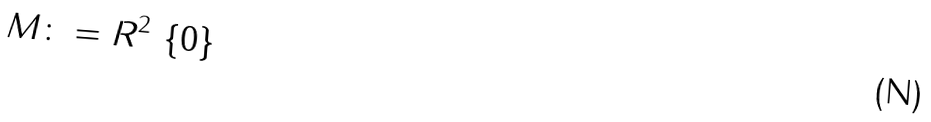Convert formula to latex. <formula><loc_0><loc_0><loc_500><loc_500>M \colon = R ^ { 2 } \ \{ 0 \}</formula> 